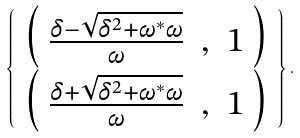<formula> <loc_0><loc_0><loc_500><loc_500>\left \{ \begin{array} { c } { { \left ( \begin{array} { c l c } { { \frac { \delta - \sqrt { \delta ^ { 2 } + \omega ^ { \ast } \omega } } { \omega } } } & { , } & { 1 } \end{array} \right ) } } \\ { { \left ( \begin{array} { c l c } { { \frac { \delta + \sqrt { \delta ^ { 2 } + \omega ^ { \ast } \omega } } { \omega } } } & { , } & { 1 } \end{array} \right ) } } \end{array} \right \} .</formula> 